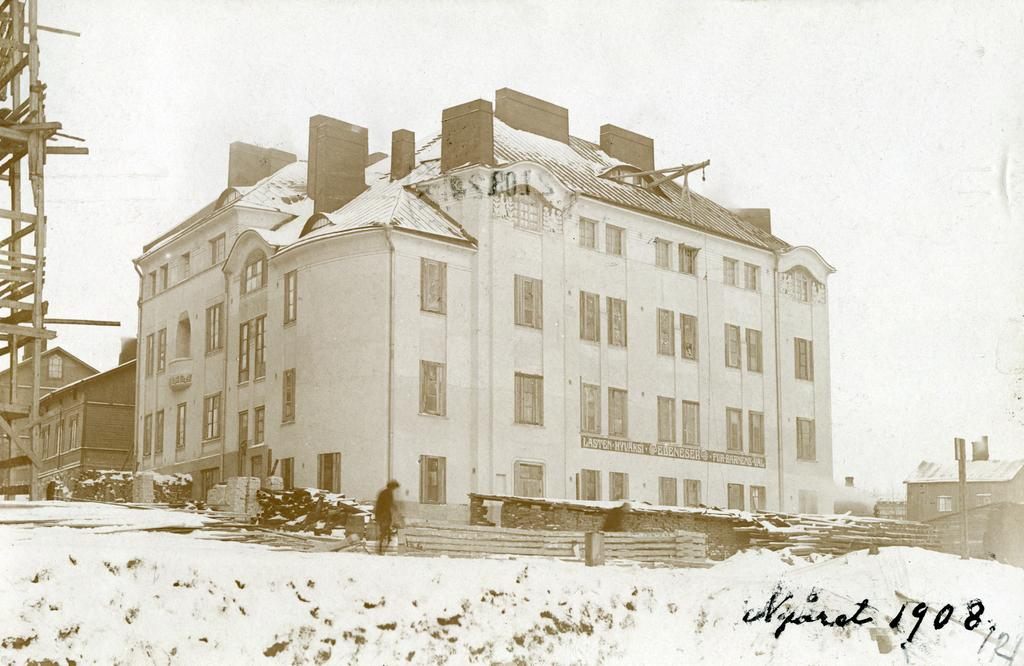What is the main subject of the image? There is a person on the ground in the image. What can be seen in the background of the image? The sky is visible in the background of the image. What type of structure is present in the image? There are buildings with windows in the image. What is the barrier that separates the person from the buildings? There is a fence in the image. Can you see the person's face in the image? The provided facts do not mention the person's face, so it cannot be determined whether it is visible in the image. 